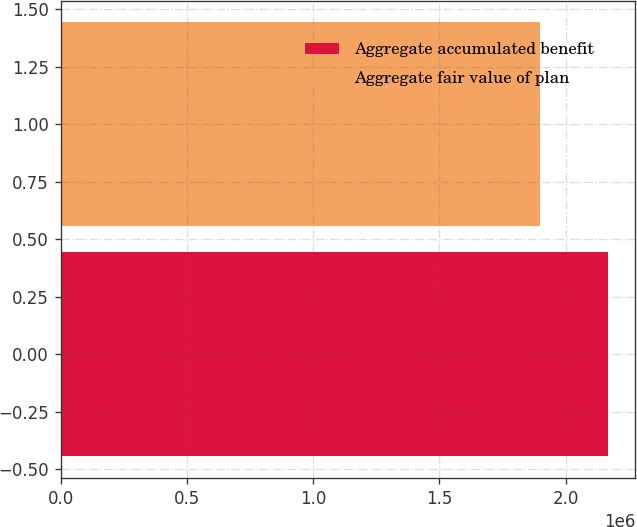<chart> <loc_0><loc_0><loc_500><loc_500><bar_chart><fcel>Aggregate accumulated benefit<fcel>Aggregate fair value of plan<nl><fcel>2.16722e+06<fcel>1.89646e+06<nl></chart> 